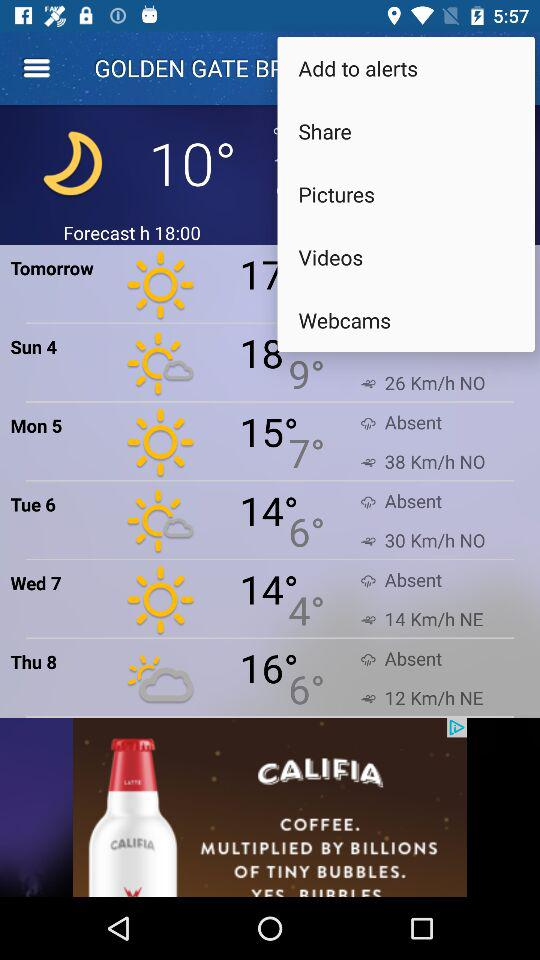How will be the Weather of Tomorrow?
When the provided information is insufficient, respond with <no answer>. <no answer> 